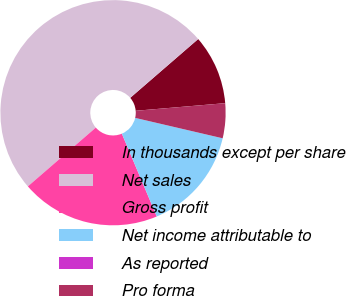Convert chart. <chart><loc_0><loc_0><loc_500><loc_500><pie_chart><fcel>In thousands except per share<fcel>Net sales<fcel>Gross profit<fcel>Net income attributable to<fcel>As reported<fcel>Pro forma<nl><fcel>10.0%<fcel>50.0%<fcel>20.0%<fcel>15.0%<fcel>0.0%<fcel>5.0%<nl></chart> 